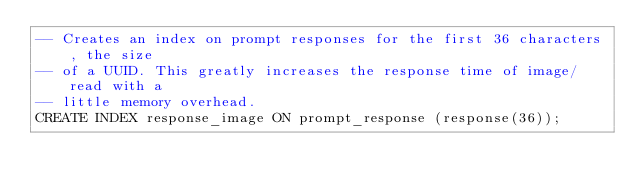<code> <loc_0><loc_0><loc_500><loc_500><_SQL_>-- Creates an index on prompt responses for the first 36 characters, the size 
-- of a UUID. This greatly increases the response time of image/read with a 
-- little memory overhead.
CREATE INDEX response_image ON prompt_response (response(36));
</code> 